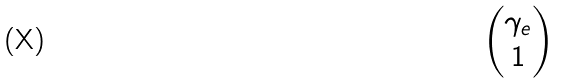Convert formula to latex. <formula><loc_0><loc_0><loc_500><loc_500>\begin{pmatrix} \gamma _ { e } \\ 1 \end{pmatrix}</formula> 